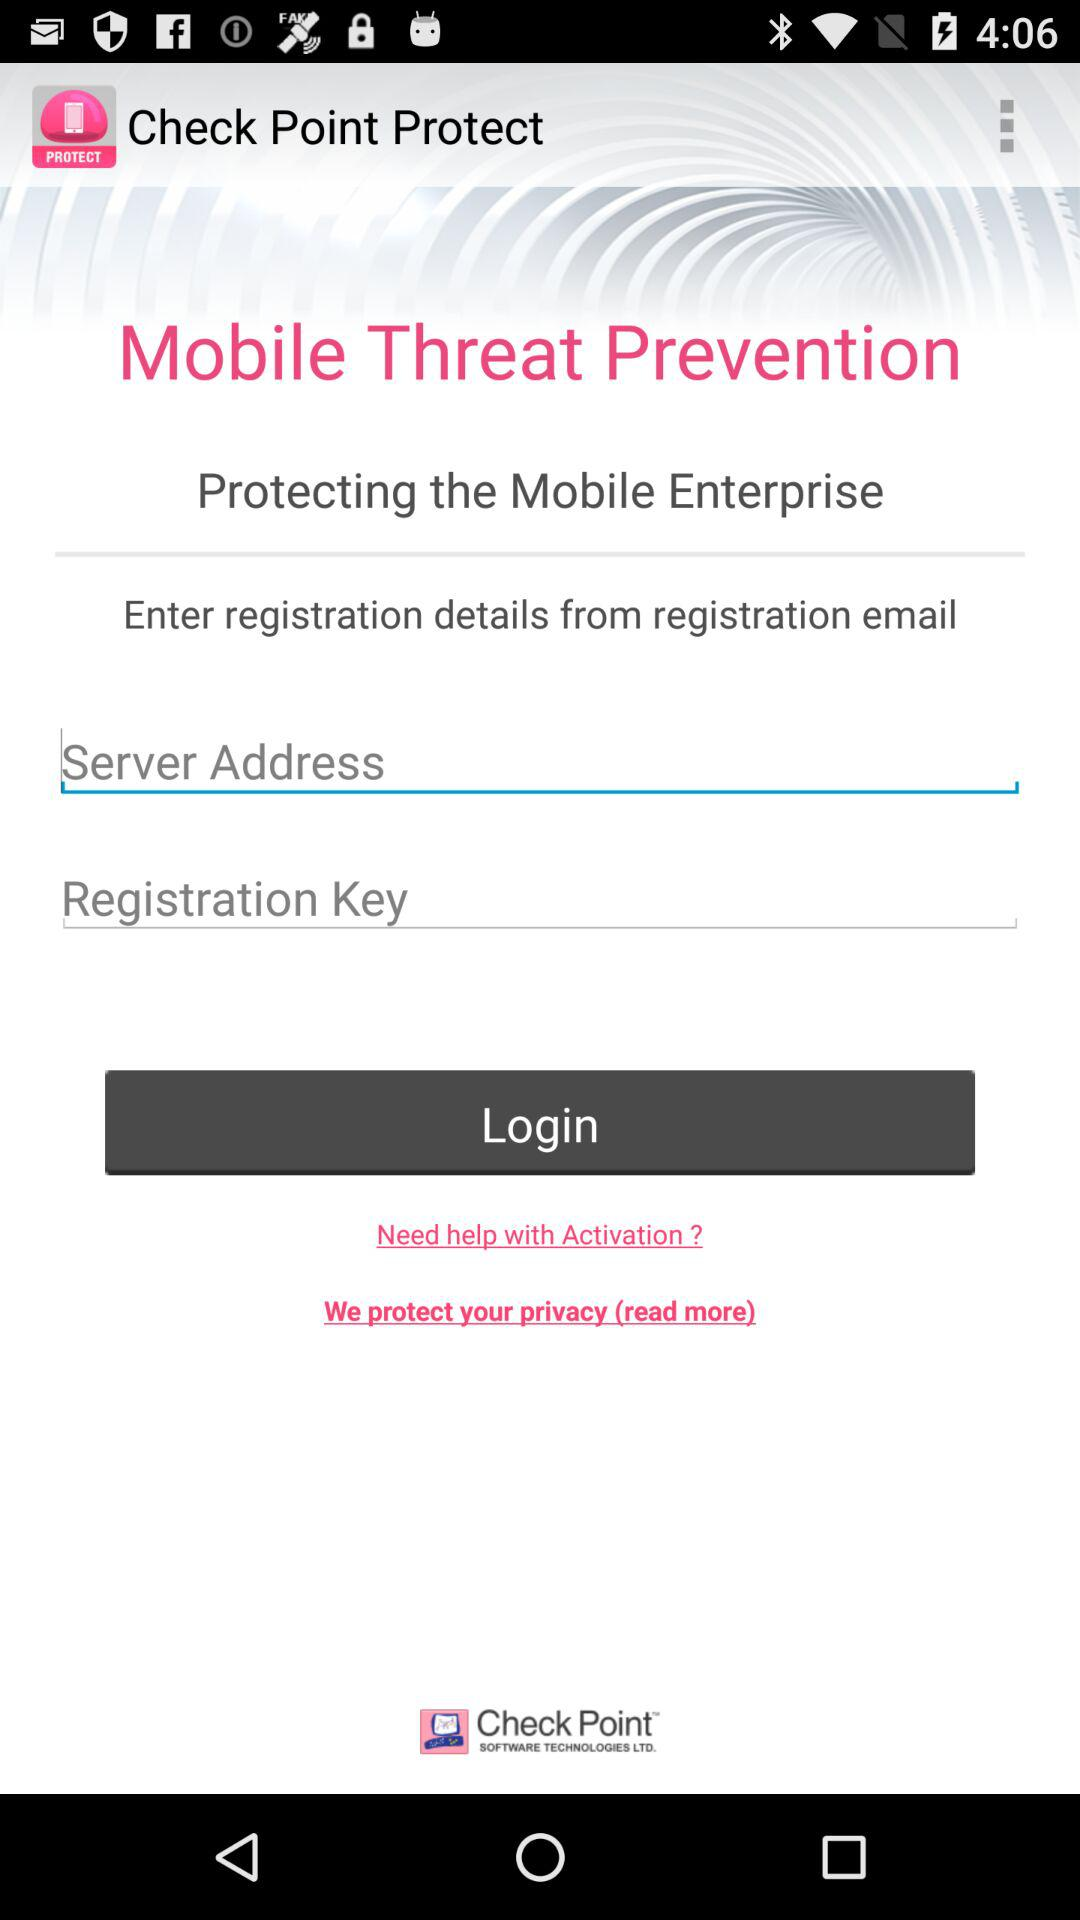What is the name of the application? The name of the application is "Check Point Protect". 